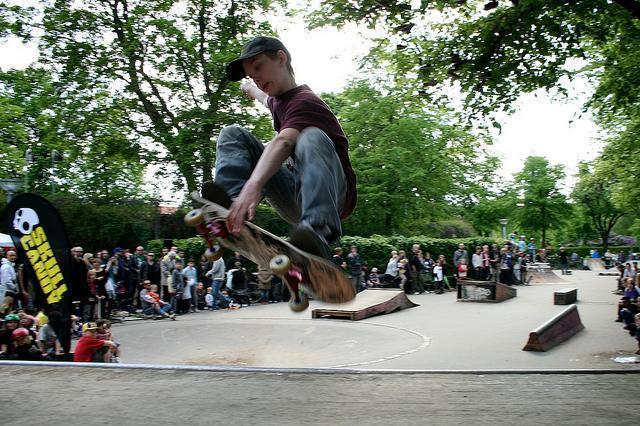How many people are there?
Give a very brief answer. 2. 